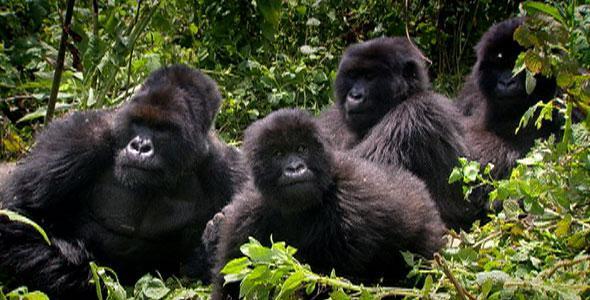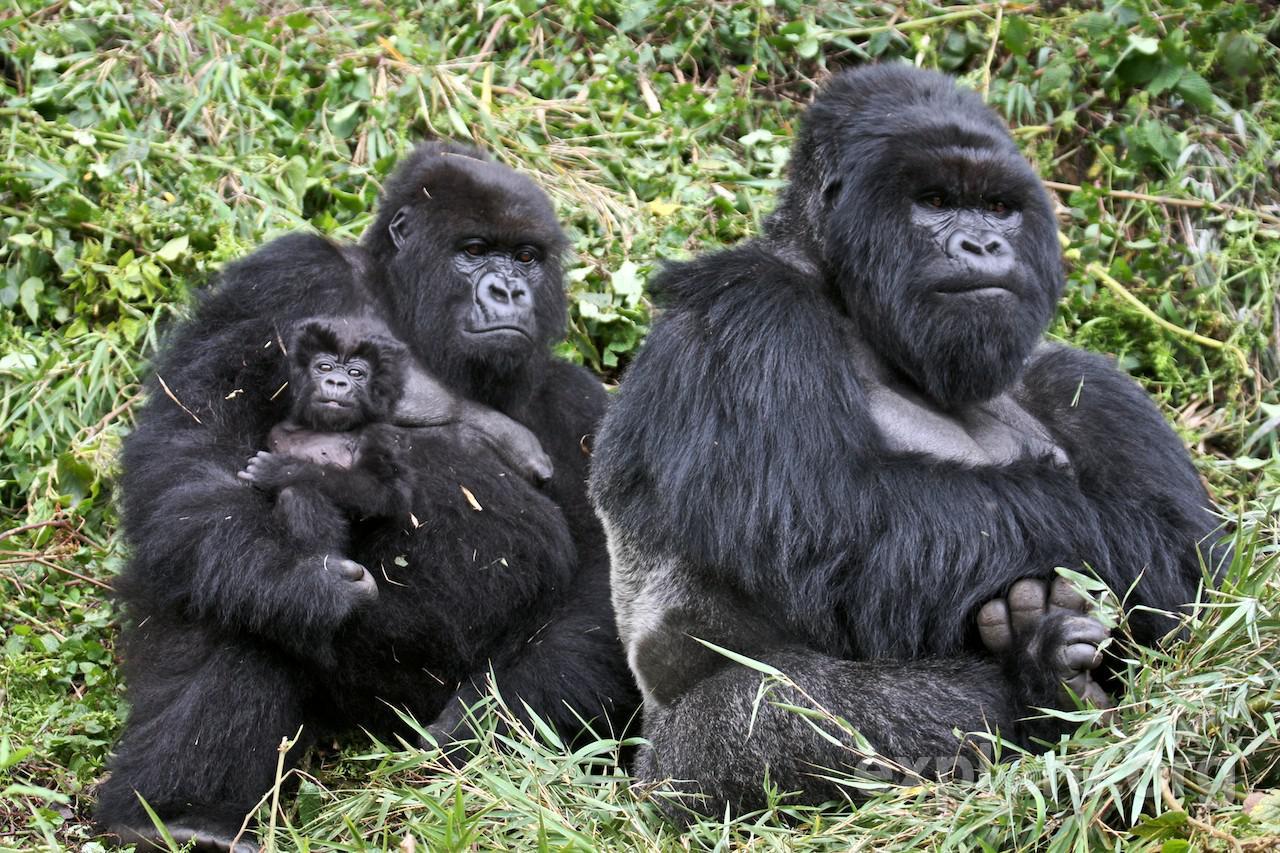The first image is the image on the left, the second image is the image on the right. Evaluate the accuracy of this statement regarding the images: "One of the images features a lone male.". Is it true? Answer yes or no. No. The first image is the image on the left, the second image is the image on the right. Assess this claim about the two images: "One gorilla is carrying a baby gorilla on its back.". Correct or not? Answer yes or no. No. 